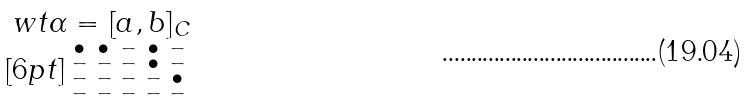Convert formula to latex. <formula><loc_0><loc_0><loc_500><loc_500>\begin{matrix} \ w t { \alpha } = [ a , b ] _ { C } \\ [ 6 p t ] \begin{smallmatrix} \bullet & \bullet & - & \bullet & - \\ - & - & - & \bullet & - \\ - & - & - & - & \bullet \\ - & - & - & - & - \end{smallmatrix} \end{matrix}</formula> 